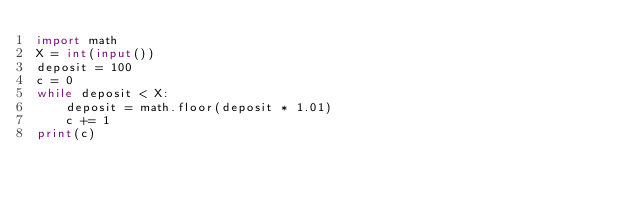Convert code to text. <code><loc_0><loc_0><loc_500><loc_500><_Python_>import math
X = int(input())
deposit = 100
c = 0
while deposit < X:
    deposit = math.floor(deposit * 1.01)
    c += 1
print(c)
</code> 